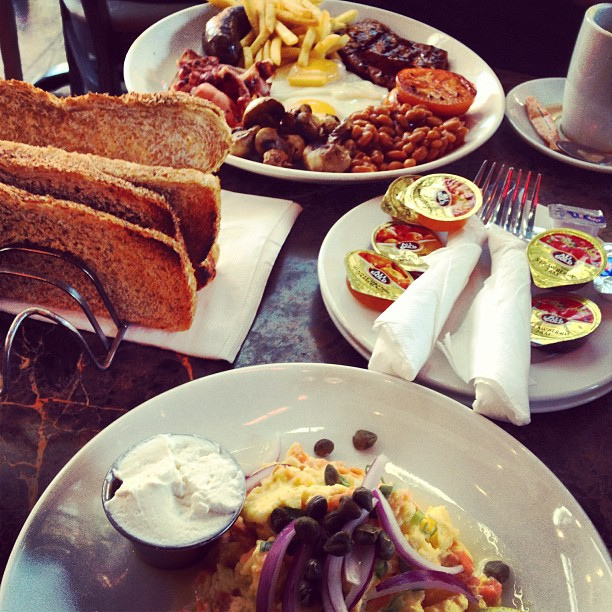If the person eating this breakfast was writing a letter, what would they say about the meal? Dear Friend, 

Today I indulged in a delightful, hearty breakfast that truly made my morning special. The plate was a wonderful assortment of flavors, from the savory beans and crispy bacon to the juicy, grilled sausage and perfectly cooked eggs. The toast was warm and crunchy, perfect with the sweet jelly and preserves. A steaming mug of coffee complemented the meal beautifully. It was a feast not just for the stomach, but for the senses as well. I wish you could have been here to share it with me.

Warm regards,
[Your Name] 